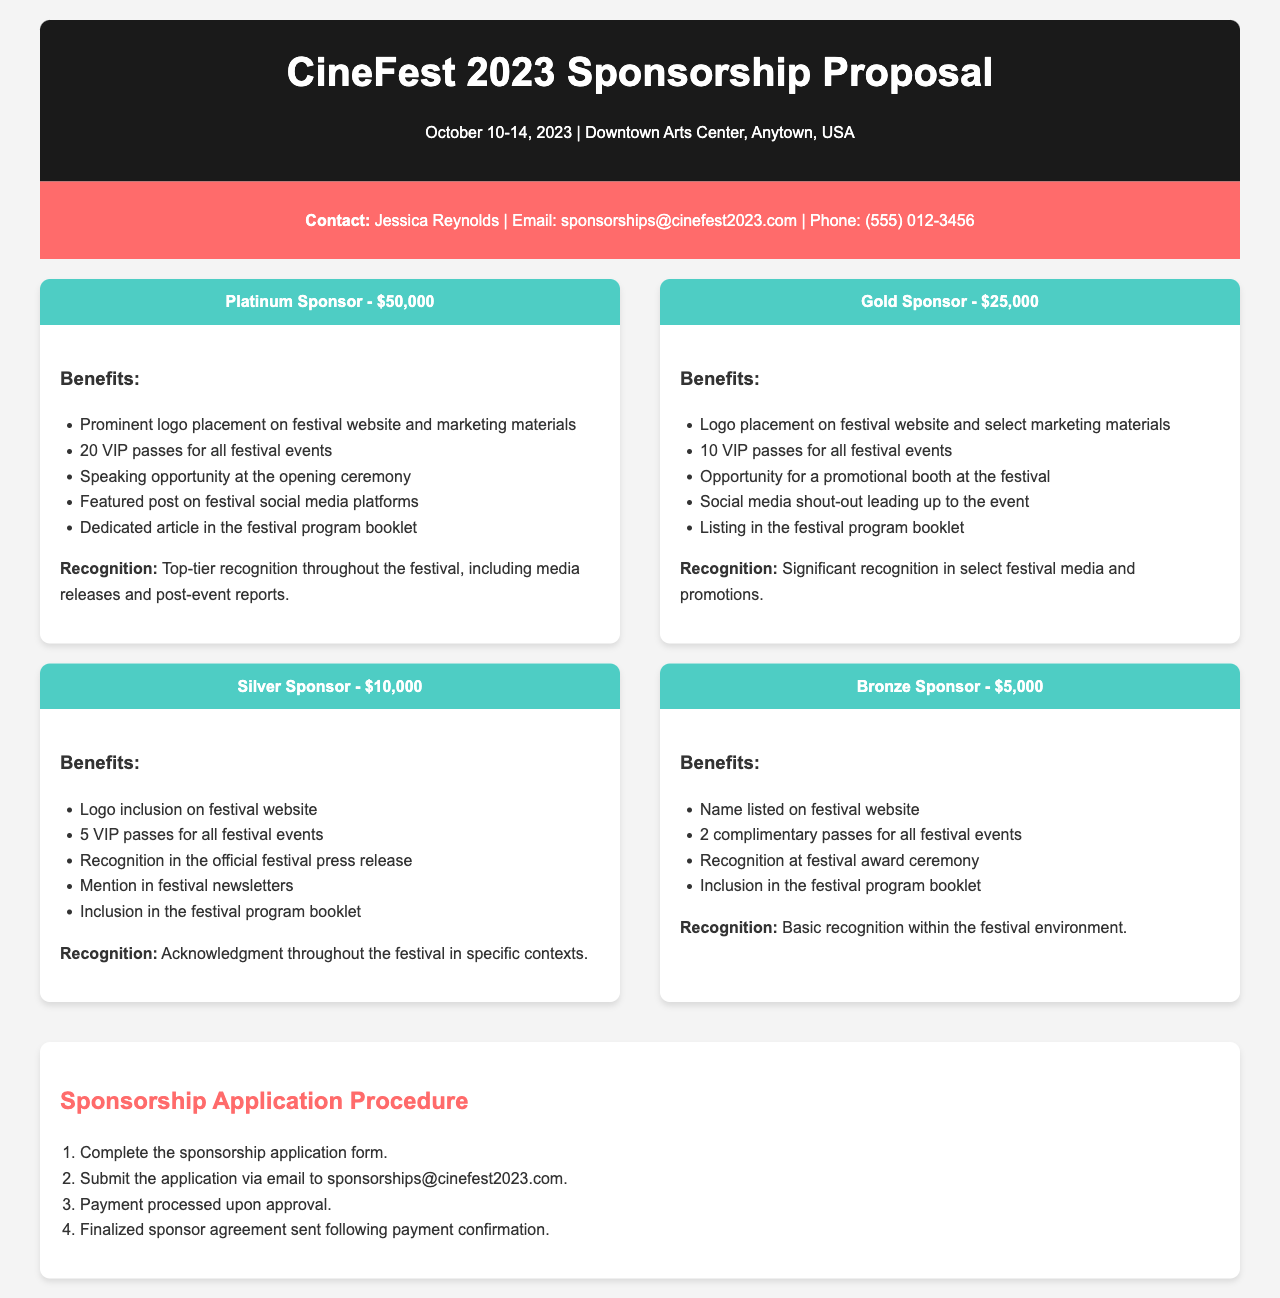What are the dates of the festival? The dates of the festival are clearly stated in the header section of the document, which is October 10-14, 2023.
Answer: October 10-14, 2023 Who is the contact person for sponsorship inquiries? The contact information provided in the document names Jessica Reynolds as the contact person for sponsorship inquiries.
Answer: Jessica Reynolds What is the amount for a Platinum sponsorship? The document specifies the fee for a Platinum sponsorship level, which is stated as $50,000.
Answer: $50,000 How many VIP passes does a Gold sponsor receive? The benefits section for the Gold Sponsor indicates that they receive 10 VIP passes for all festival events.
Answer: 10 VIP passes What type of recognition does a Silver Sponsor receive? The recognition section for a Silver Sponsor mentions "Acknowledgment throughout the festival in specific contexts," which indicates their level of recognition.
Answer: Acknowledgment throughout the festival in specific contexts What is the first step in the sponsorship application procedure? The application procedure lists the first step as completing the sponsorship application form.
Answer: Complete the sponsorship application form How many complimentary passes does a Bronze Sponsor get? The benefits for a Bronze Sponsor state they receive 2 complimentary passes for all festival events.
Answer: 2 complimentary passes What is included in the benefits for a Platinum Sponsor? The benefits section outlines multiple inclusions for the Platinum Sponsor, such as prominent logo placement and VIP passes, making it crucial to summarize these components.
Answer: Prominent logo placement on festival website and marketing materials, 20 VIP passes, speaking opportunity at opening ceremony, featured post on social media, dedicated article in program booklet What is the email address for submitting the sponsorship application? The contact information section specifies the email for submission, which is given as sponsorships@cinefest2023.com.
Answer: sponsorships@cinefest2023.com 